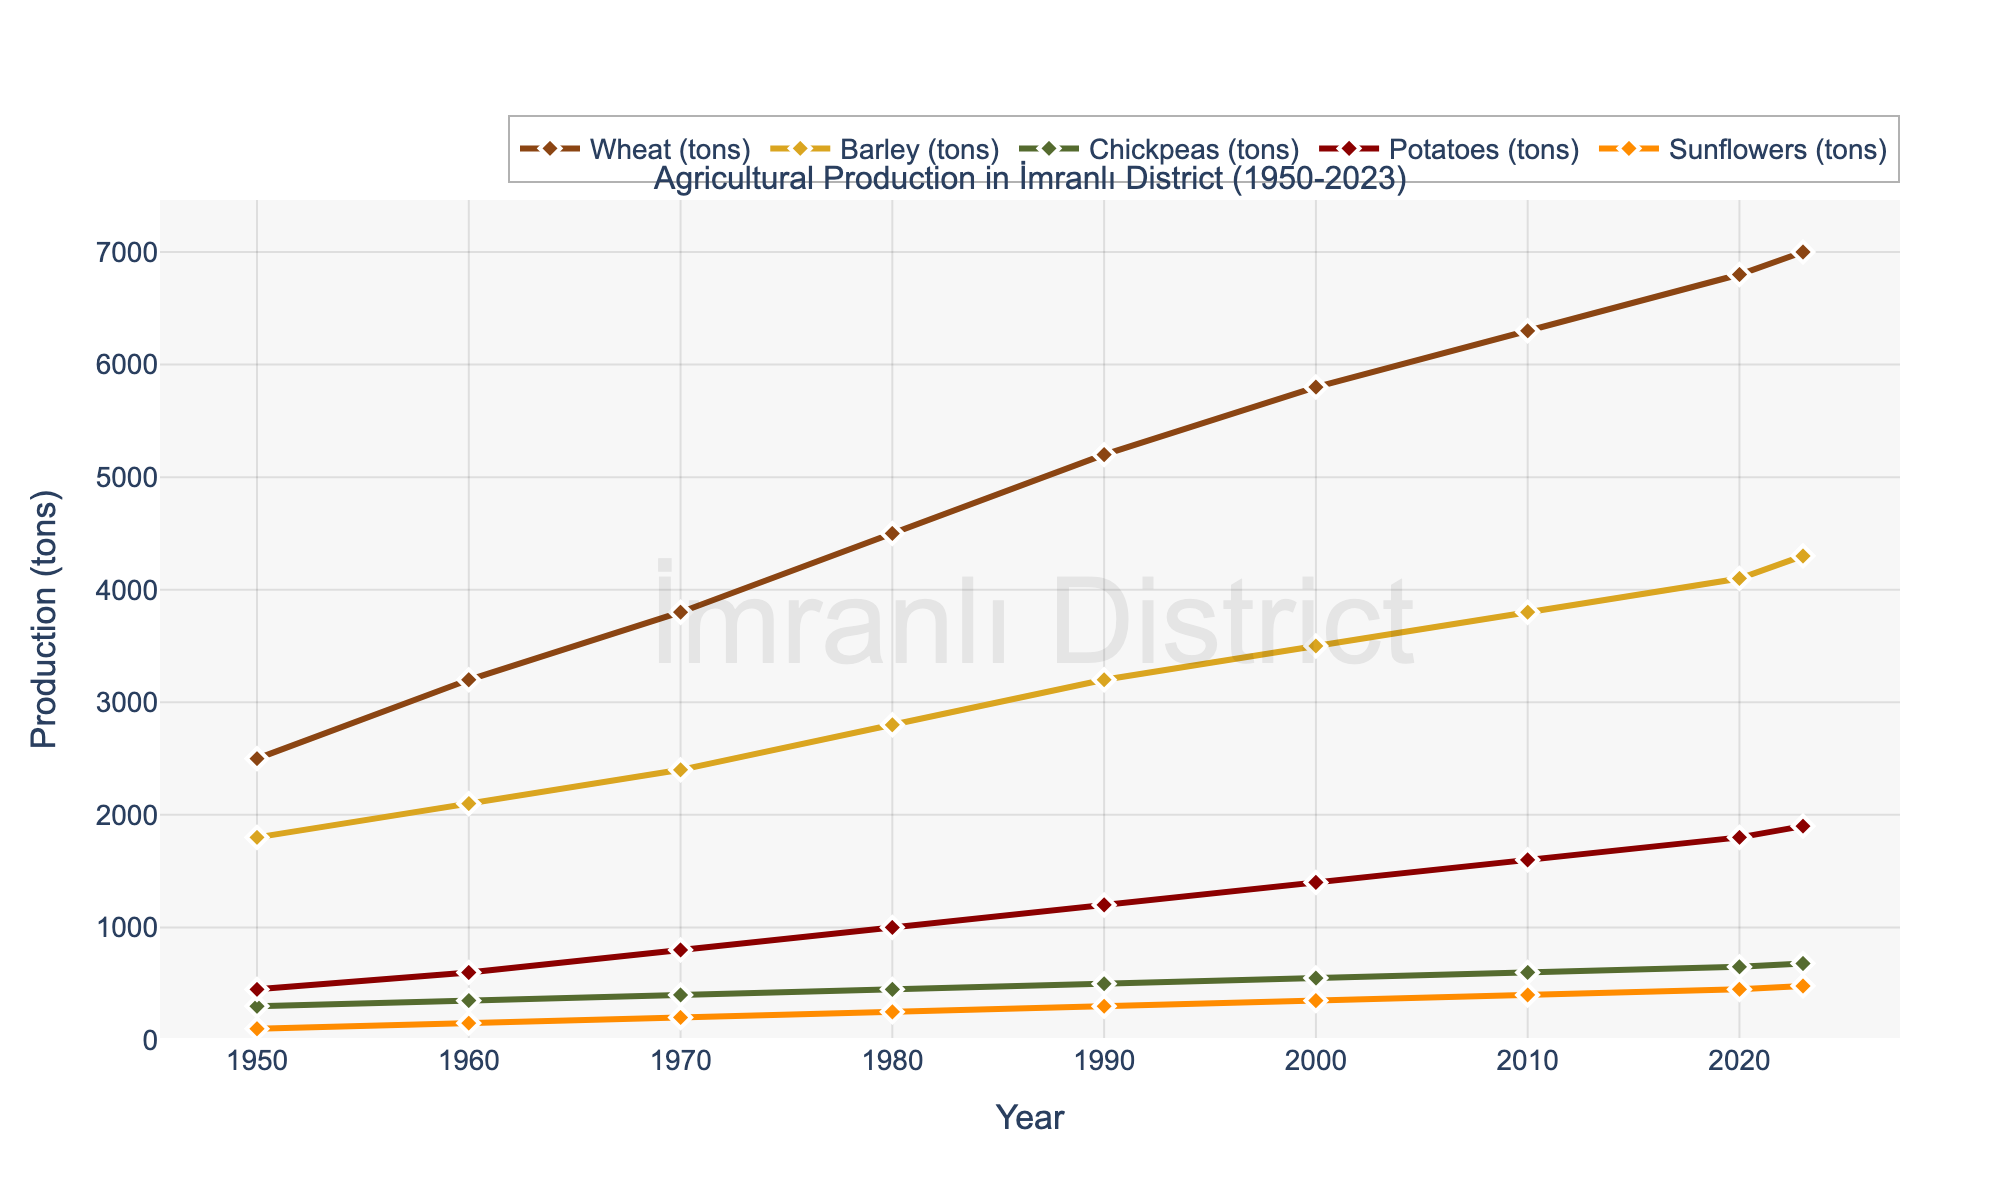What is the overall trend of wheat production from 1950 to 2023? The figure shows a consistent increase in wheat production over time. Starting from 2500 tons in 1950, it reaches 7000 tons by 2023.
Answer: Increasing Which crop showed the smallest overall increase in production from 1950 to 2023? By examining the final values in the chart, chickpeas increased from 300 tons to 680 tons, which is lower compared to the increases shown by other crops.
Answer: Chickpeas What is the difference in barley production between 1980 and 2023? Barley production in 1980 was 2800 tons, and in 2023 it was 4300 tons. The difference is 4300 - 2800.
Answer: 1500 tons Which crop had the highest production in 2023? By observing the end point of the lines in the chart for 2023, wheat has the highest production at 7000 tons.
Answer: Wheat How did potato production change between 1990 and 2010? In 1990, potato production was 1200 tons. In 2010, it increased to 1600 tons. The change is 1600 - 1200.
Answer: Increased by 400 tons Compare the production of sunflowers and potatoes in 1960. Which one was higher? In 1960, potatoes had a production of 600 tons, and sunflowers had 150 tons. Potatoes were higher.
Answer: Potatoes What is the average production of chickpeas across the entire time period? Add all the yearly chickpea production values and divide by the number of years (300 + 350 + 400 + 450 + 500 + 550 + 600 + 650 + 680) / 9.
Answer: 497.78 tons Which crop had the sharpest increase in production per decade? Wheat shows the steepest slope in the chart, indicating the largest increase per decade compared to other crops.
Answer: Wheat In which year did barley production exceed 3000 tons for the first time? By observing the upward trend of barley, barley production first exceeds 3000 tons in 1990, where it reaches 3200 tons.
Answer: 1990 What is the combined production of wheat and barley in 2023? Wheat production in 2023 is 7000 tons, and barley production is 4300 tons. Their combined production is 7000 + 4300.
Answer: 11300 tons 